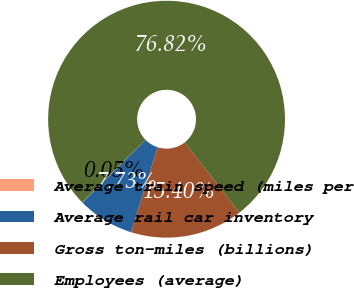Convert chart. <chart><loc_0><loc_0><loc_500><loc_500><pie_chart><fcel>Average train speed (miles per<fcel>Average rail car inventory<fcel>Gross ton-miles (billions)<fcel>Employees (average)<nl><fcel>0.05%<fcel>7.73%<fcel>15.4%<fcel>76.82%<nl></chart> 